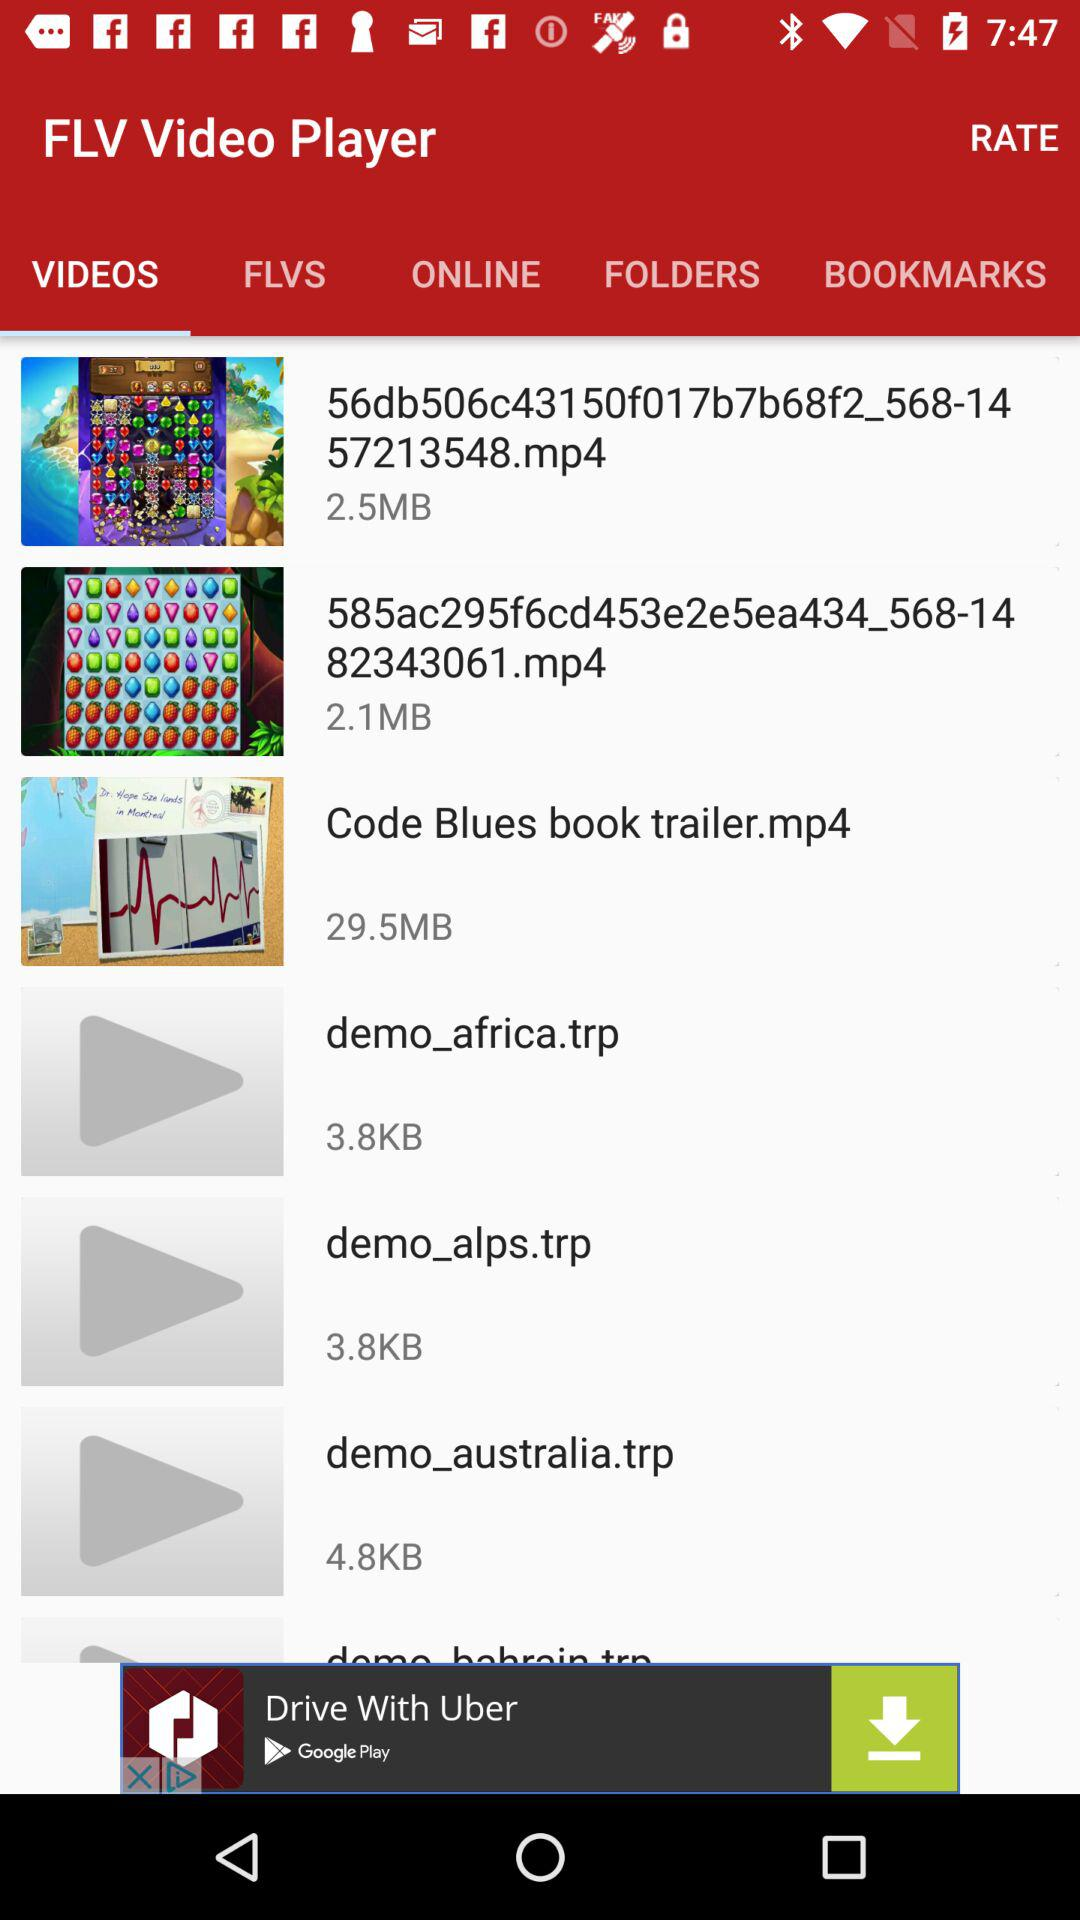What is the name of the file whose size is 2.5 MB? The name of the file is "56db506c43150f017b7b68f2_568-1457213548.mp4". 